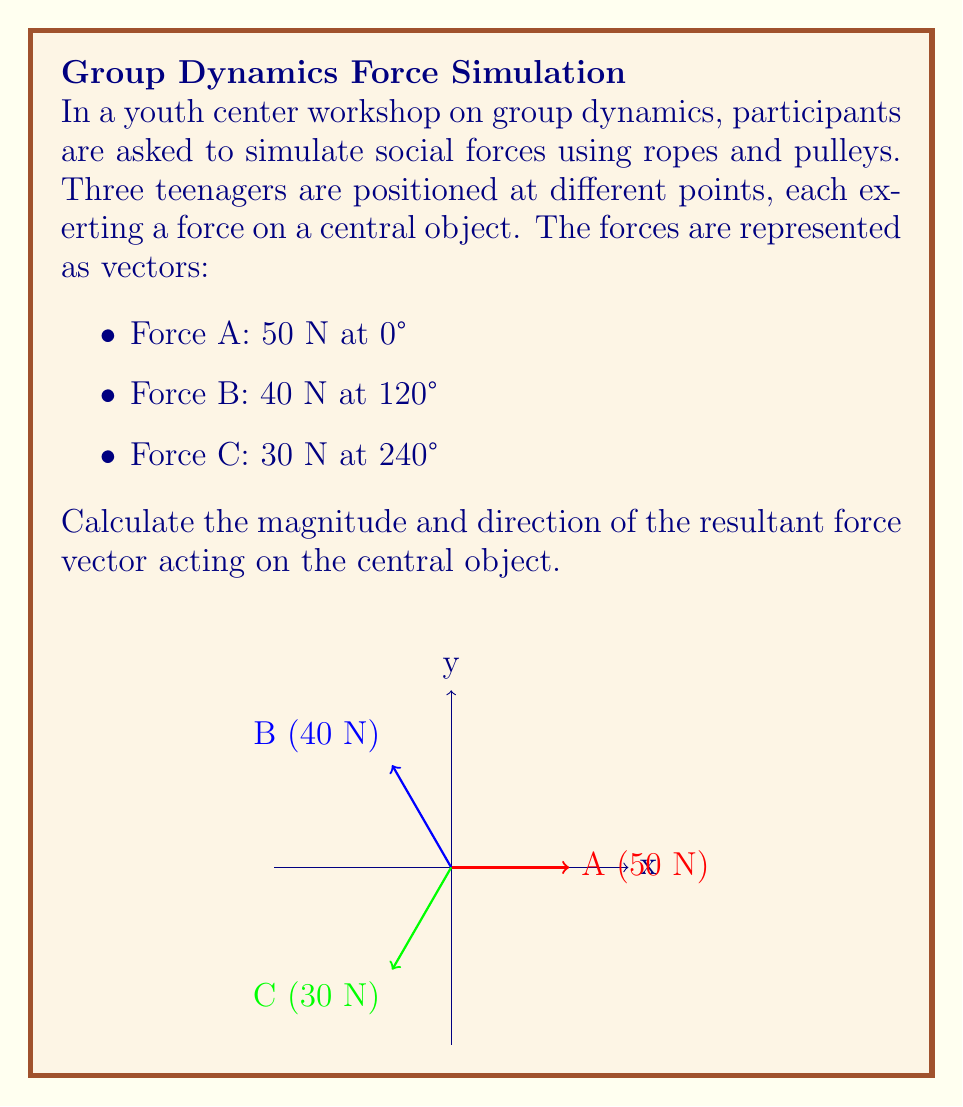Teach me how to tackle this problem. To find the resultant force vector, we need to add the three force vectors. We'll do this by breaking each vector into its x and y components, then adding them separately.

1) Convert each force to rectangular components:

   Force A: $F_{Ax} = 50 \cos(0°) = 50$ N,  $F_{Ay} = 50 \sin(0°) = 0$ N
   Force B: $F_{Bx} = 40 \cos(120°) = -20$ N,  $F_{By} = 40 \sin(120°) = 34.64$ N
   Force C: $F_{Cx} = 30 \cos(240°) = -15$ N,  $F_{Cy} = 30 \sin(240°) = -25.98$ N

2) Sum the x and y components:

   $F_x = F_{Ax} + F_{Bx} + F_{Cx} = 50 + (-20) + (-15) = 15$ N
   $F_y = F_{Ay} + F_{By} + F_{Cy} = 0 + 34.64 + (-25.98) = 8.66$ N

3) Calculate the magnitude of the resultant force using the Pythagorean theorem:

   $F_R = \sqrt{F_x^2 + F_y^2} = \sqrt{15^2 + 8.66^2} = 17.32$ N

4) Calculate the direction of the resultant force using the arctangent function:

   $\theta = \tan^{-1}(\frac{F_y}{F_x}) = \tan^{-1}(\frac{8.66}{15}) = 30°$

Therefore, the resultant force has a magnitude of 17.32 N and acts at an angle of 30° from the positive x-axis.
Answer: 17.32 N at 30° 